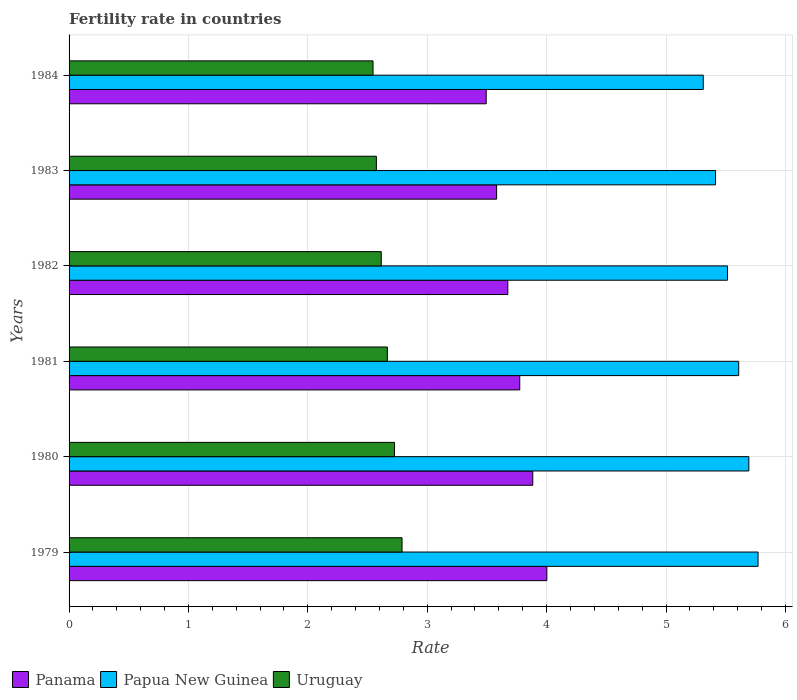Are the number of bars per tick equal to the number of legend labels?
Your response must be concise. Yes. Are the number of bars on each tick of the Y-axis equal?
Your answer should be very brief. Yes. How many bars are there on the 2nd tick from the bottom?
Provide a short and direct response. 3. In how many cases, is the number of bars for a given year not equal to the number of legend labels?
Your answer should be compact. 0. What is the fertility rate in Panama in 1980?
Your answer should be very brief. 3.88. Across all years, what is the maximum fertility rate in Papua New Guinea?
Give a very brief answer. 5.77. Across all years, what is the minimum fertility rate in Papua New Guinea?
Make the answer very short. 5.31. In which year was the fertility rate in Papua New Guinea maximum?
Provide a short and direct response. 1979. What is the total fertility rate in Panama in the graph?
Keep it short and to the point. 22.41. What is the difference between the fertility rate in Papua New Guinea in 1980 and that in 1984?
Keep it short and to the point. 0.38. What is the difference between the fertility rate in Uruguay in 1979 and the fertility rate in Papua New Guinea in 1984?
Your response must be concise. -2.52. What is the average fertility rate in Papua New Guinea per year?
Provide a succinct answer. 5.55. In the year 1981, what is the difference between the fertility rate in Panama and fertility rate in Papua New Guinea?
Ensure brevity in your answer.  -1.83. What is the ratio of the fertility rate in Panama in 1980 to that in 1982?
Keep it short and to the point. 1.06. Is the difference between the fertility rate in Panama in 1980 and 1983 greater than the difference between the fertility rate in Papua New Guinea in 1980 and 1983?
Your response must be concise. Yes. What is the difference between the highest and the second highest fertility rate in Uruguay?
Your response must be concise. 0.06. What is the difference between the highest and the lowest fertility rate in Uruguay?
Ensure brevity in your answer.  0.24. In how many years, is the fertility rate in Uruguay greater than the average fertility rate in Uruguay taken over all years?
Provide a short and direct response. 3. Is the sum of the fertility rate in Panama in 1982 and 1984 greater than the maximum fertility rate in Uruguay across all years?
Your answer should be very brief. Yes. What does the 2nd bar from the top in 1979 represents?
Offer a very short reply. Papua New Guinea. What does the 2nd bar from the bottom in 1983 represents?
Your response must be concise. Papua New Guinea. Is it the case that in every year, the sum of the fertility rate in Panama and fertility rate in Uruguay is greater than the fertility rate in Papua New Guinea?
Give a very brief answer. Yes. How many years are there in the graph?
Provide a short and direct response. 6. What is the difference between two consecutive major ticks on the X-axis?
Your response must be concise. 1. Where does the legend appear in the graph?
Provide a succinct answer. Bottom left. What is the title of the graph?
Keep it short and to the point. Fertility rate in countries. Does "Guatemala" appear as one of the legend labels in the graph?
Offer a very short reply. No. What is the label or title of the X-axis?
Your response must be concise. Rate. What is the label or title of the Y-axis?
Your answer should be very brief. Years. What is the Rate in Panama in 1979?
Offer a terse response. 4. What is the Rate in Papua New Guinea in 1979?
Your answer should be very brief. 5.77. What is the Rate of Uruguay in 1979?
Give a very brief answer. 2.79. What is the Rate in Panama in 1980?
Offer a terse response. 3.88. What is the Rate in Papua New Guinea in 1980?
Your answer should be compact. 5.69. What is the Rate of Uruguay in 1980?
Provide a succinct answer. 2.73. What is the Rate of Panama in 1981?
Your response must be concise. 3.77. What is the Rate in Papua New Guinea in 1981?
Your answer should be compact. 5.61. What is the Rate in Uruguay in 1981?
Ensure brevity in your answer.  2.67. What is the Rate in Panama in 1982?
Keep it short and to the point. 3.67. What is the Rate in Papua New Guinea in 1982?
Offer a terse response. 5.51. What is the Rate in Uruguay in 1982?
Your response must be concise. 2.62. What is the Rate of Panama in 1983?
Provide a succinct answer. 3.58. What is the Rate of Papua New Guinea in 1983?
Your answer should be compact. 5.42. What is the Rate in Uruguay in 1983?
Your answer should be very brief. 2.57. What is the Rate in Panama in 1984?
Provide a short and direct response. 3.49. What is the Rate in Papua New Guinea in 1984?
Your answer should be very brief. 5.31. What is the Rate in Uruguay in 1984?
Ensure brevity in your answer.  2.55. Across all years, what is the maximum Rate of Panama?
Provide a short and direct response. 4. Across all years, what is the maximum Rate in Papua New Guinea?
Offer a terse response. 5.77. Across all years, what is the maximum Rate in Uruguay?
Your answer should be compact. 2.79. Across all years, what is the minimum Rate of Panama?
Provide a short and direct response. 3.49. Across all years, what is the minimum Rate in Papua New Guinea?
Your response must be concise. 5.31. Across all years, what is the minimum Rate of Uruguay?
Make the answer very short. 2.55. What is the total Rate of Panama in the graph?
Provide a succinct answer. 22.41. What is the total Rate in Papua New Guinea in the graph?
Ensure brevity in your answer.  33.32. What is the total Rate in Uruguay in the graph?
Your answer should be very brief. 15.92. What is the difference between the Rate in Panama in 1979 and that in 1980?
Keep it short and to the point. 0.12. What is the difference between the Rate in Papua New Guinea in 1979 and that in 1980?
Make the answer very short. 0.08. What is the difference between the Rate in Uruguay in 1979 and that in 1980?
Give a very brief answer. 0.06. What is the difference between the Rate of Panama in 1979 and that in 1981?
Provide a short and direct response. 0.23. What is the difference between the Rate of Papua New Guinea in 1979 and that in 1981?
Keep it short and to the point. 0.16. What is the difference between the Rate in Uruguay in 1979 and that in 1981?
Offer a terse response. 0.12. What is the difference between the Rate in Panama in 1979 and that in 1982?
Offer a very short reply. 0.33. What is the difference between the Rate of Papua New Guinea in 1979 and that in 1982?
Make the answer very short. 0.26. What is the difference between the Rate in Uruguay in 1979 and that in 1982?
Provide a succinct answer. 0.17. What is the difference between the Rate in Panama in 1979 and that in 1983?
Provide a short and direct response. 0.42. What is the difference between the Rate of Papua New Guinea in 1979 and that in 1983?
Offer a very short reply. 0.36. What is the difference between the Rate of Uruguay in 1979 and that in 1983?
Your answer should be compact. 0.21. What is the difference between the Rate of Panama in 1979 and that in 1984?
Ensure brevity in your answer.  0.51. What is the difference between the Rate in Papua New Guinea in 1979 and that in 1984?
Your answer should be very brief. 0.46. What is the difference between the Rate of Uruguay in 1979 and that in 1984?
Provide a short and direct response. 0.24. What is the difference between the Rate in Panama in 1980 and that in 1981?
Give a very brief answer. 0.11. What is the difference between the Rate in Papua New Guinea in 1980 and that in 1981?
Give a very brief answer. 0.09. What is the difference between the Rate of Panama in 1980 and that in 1982?
Offer a very short reply. 0.21. What is the difference between the Rate in Papua New Guinea in 1980 and that in 1982?
Provide a short and direct response. 0.18. What is the difference between the Rate of Uruguay in 1980 and that in 1982?
Your answer should be very brief. 0.11. What is the difference between the Rate in Panama in 1980 and that in 1983?
Keep it short and to the point. 0.3. What is the difference between the Rate of Papua New Guinea in 1980 and that in 1983?
Provide a succinct answer. 0.28. What is the difference between the Rate in Uruguay in 1980 and that in 1983?
Your answer should be very brief. 0.15. What is the difference between the Rate of Panama in 1980 and that in 1984?
Provide a succinct answer. 0.39. What is the difference between the Rate in Papua New Guinea in 1980 and that in 1984?
Keep it short and to the point. 0.38. What is the difference between the Rate in Uruguay in 1980 and that in 1984?
Your answer should be compact. 0.18. What is the difference between the Rate of Papua New Guinea in 1981 and that in 1982?
Offer a very short reply. 0.09. What is the difference between the Rate of Uruguay in 1981 and that in 1982?
Your response must be concise. 0.05. What is the difference between the Rate in Panama in 1981 and that in 1983?
Your answer should be very brief. 0.19. What is the difference between the Rate of Papua New Guinea in 1981 and that in 1983?
Provide a short and direct response. 0.19. What is the difference between the Rate of Uruguay in 1981 and that in 1983?
Offer a terse response. 0.09. What is the difference between the Rate in Panama in 1981 and that in 1984?
Provide a succinct answer. 0.28. What is the difference between the Rate in Papua New Guinea in 1981 and that in 1984?
Keep it short and to the point. 0.3. What is the difference between the Rate of Uruguay in 1981 and that in 1984?
Provide a succinct answer. 0.12. What is the difference between the Rate in Panama in 1982 and that in 1983?
Keep it short and to the point. 0.09. What is the difference between the Rate of Papua New Guinea in 1982 and that in 1983?
Keep it short and to the point. 0.1. What is the difference between the Rate of Uruguay in 1982 and that in 1983?
Ensure brevity in your answer.  0.04. What is the difference between the Rate of Panama in 1982 and that in 1984?
Your answer should be very brief. 0.18. What is the difference between the Rate of Papua New Guinea in 1982 and that in 1984?
Make the answer very short. 0.2. What is the difference between the Rate in Uruguay in 1982 and that in 1984?
Keep it short and to the point. 0.07. What is the difference between the Rate in Panama in 1983 and that in 1984?
Give a very brief answer. 0.09. What is the difference between the Rate in Papua New Guinea in 1983 and that in 1984?
Your answer should be very brief. 0.1. What is the difference between the Rate of Uruguay in 1983 and that in 1984?
Provide a succinct answer. 0.03. What is the difference between the Rate in Panama in 1979 and the Rate in Papua New Guinea in 1980?
Your answer should be compact. -1.69. What is the difference between the Rate of Panama in 1979 and the Rate of Uruguay in 1980?
Your answer should be very brief. 1.28. What is the difference between the Rate of Papua New Guinea in 1979 and the Rate of Uruguay in 1980?
Offer a very short reply. 3.04. What is the difference between the Rate of Panama in 1979 and the Rate of Papua New Guinea in 1981?
Ensure brevity in your answer.  -1.61. What is the difference between the Rate of Panama in 1979 and the Rate of Uruguay in 1981?
Make the answer very short. 1.34. What is the difference between the Rate in Papua New Guinea in 1979 and the Rate in Uruguay in 1981?
Offer a terse response. 3.1. What is the difference between the Rate of Panama in 1979 and the Rate of Papua New Guinea in 1982?
Make the answer very short. -1.51. What is the difference between the Rate of Panama in 1979 and the Rate of Uruguay in 1982?
Provide a succinct answer. 1.39. What is the difference between the Rate in Papua New Guinea in 1979 and the Rate in Uruguay in 1982?
Your answer should be very brief. 3.16. What is the difference between the Rate in Panama in 1979 and the Rate in Papua New Guinea in 1983?
Your response must be concise. -1.41. What is the difference between the Rate in Panama in 1979 and the Rate in Uruguay in 1983?
Offer a terse response. 1.43. What is the difference between the Rate of Papua New Guinea in 1979 and the Rate of Uruguay in 1983?
Your answer should be compact. 3.2. What is the difference between the Rate of Panama in 1979 and the Rate of Papua New Guinea in 1984?
Your response must be concise. -1.31. What is the difference between the Rate in Panama in 1979 and the Rate in Uruguay in 1984?
Your answer should be compact. 1.46. What is the difference between the Rate in Papua New Guinea in 1979 and the Rate in Uruguay in 1984?
Make the answer very short. 3.23. What is the difference between the Rate of Panama in 1980 and the Rate of Papua New Guinea in 1981?
Provide a short and direct response. -1.73. What is the difference between the Rate in Panama in 1980 and the Rate in Uruguay in 1981?
Your answer should be very brief. 1.22. What is the difference between the Rate of Papua New Guinea in 1980 and the Rate of Uruguay in 1981?
Provide a succinct answer. 3.03. What is the difference between the Rate of Panama in 1980 and the Rate of Papua New Guinea in 1982?
Your answer should be very brief. -1.63. What is the difference between the Rate in Panama in 1980 and the Rate in Uruguay in 1982?
Ensure brevity in your answer.  1.27. What is the difference between the Rate of Papua New Guinea in 1980 and the Rate of Uruguay in 1982?
Keep it short and to the point. 3.08. What is the difference between the Rate in Panama in 1980 and the Rate in Papua New Guinea in 1983?
Offer a very short reply. -1.53. What is the difference between the Rate of Panama in 1980 and the Rate of Uruguay in 1983?
Keep it short and to the point. 1.31. What is the difference between the Rate in Papua New Guinea in 1980 and the Rate in Uruguay in 1983?
Offer a very short reply. 3.12. What is the difference between the Rate of Panama in 1980 and the Rate of Papua New Guinea in 1984?
Offer a terse response. -1.43. What is the difference between the Rate in Panama in 1980 and the Rate in Uruguay in 1984?
Provide a short and direct response. 1.34. What is the difference between the Rate in Papua New Guinea in 1980 and the Rate in Uruguay in 1984?
Your answer should be very brief. 3.15. What is the difference between the Rate of Panama in 1981 and the Rate of Papua New Guinea in 1982?
Your response must be concise. -1.74. What is the difference between the Rate of Panama in 1981 and the Rate of Uruguay in 1982?
Offer a very short reply. 1.16. What is the difference between the Rate in Papua New Guinea in 1981 and the Rate in Uruguay in 1982?
Provide a short and direct response. 2.99. What is the difference between the Rate of Panama in 1981 and the Rate of Papua New Guinea in 1983?
Give a very brief answer. -1.64. What is the difference between the Rate in Panama in 1981 and the Rate in Uruguay in 1983?
Give a very brief answer. 1.2. What is the difference between the Rate in Papua New Guinea in 1981 and the Rate in Uruguay in 1983?
Your answer should be very brief. 3.04. What is the difference between the Rate of Panama in 1981 and the Rate of Papua New Guinea in 1984?
Ensure brevity in your answer.  -1.54. What is the difference between the Rate of Panama in 1981 and the Rate of Uruguay in 1984?
Your answer should be compact. 1.23. What is the difference between the Rate in Papua New Guinea in 1981 and the Rate in Uruguay in 1984?
Offer a terse response. 3.06. What is the difference between the Rate in Panama in 1982 and the Rate in Papua New Guinea in 1983?
Your answer should be compact. -1.74. What is the difference between the Rate of Panama in 1982 and the Rate of Uruguay in 1983?
Your answer should be very brief. 1.1. What is the difference between the Rate in Papua New Guinea in 1982 and the Rate in Uruguay in 1983?
Give a very brief answer. 2.94. What is the difference between the Rate of Panama in 1982 and the Rate of Papua New Guinea in 1984?
Your response must be concise. -1.64. What is the difference between the Rate of Panama in 1982 and the Rate of Uruguay in 1984?
Make the answer very short. 1.13. What is the difference between the Rate in Papua New Guinea in 1982 and the Rate in Uruguay in 1984?
Provide a short and direct response. 2.97. What is the difference between the Rate of Panama in 1983 and the Rate of Papua New Guinea in 1984?
Ensure brevity in your answer.  -1.73. What is the difference between the Rate of Panama in 1983 and the Rate of Uruguay in 1984?
Keep it short and to the point. 1.03. What is the difference between the Rate in Papua New Guinea in 1983 and the Rate in Uruguay in 1984?
Offer a very short reply. 2.87. What is the average Rate of Panama per year?
Ensure brevity in your answer.  3.74. What is the average Rate of Papua New Guinea per year?
Offer a very short reply. 5.55. What is the average Rate of Uruguay per year?
Offer a very short reply. 2.65. In the year 1979, what is the difference between the Rate in Panama and Rate in Papua New Guinea?
Provide a short and direct response. -1.77. In the year 1979, what is the difference between the Rate in Panama and Rate in Uruguay?
Keep it short and to the point. 1.21. In the year 1979, what is the difference between the Rate in Papua New Guinea and Rate in Uruguay?
Make the answer very short. 2.98. In the year 1980, what is the difference between the Rate of Panama and Rate of Papua New Guinea?
Provide a succinct answer. -1.81. In the year 1980, what is the difference between the Rate in Panama and Rate in Uruguay?
Offer a terse response. 1.16. In the year 1980, what is the difference between the Rate in Papua New Guinea and Rate in Uruguay?
Provide a succinct answer. 2.97. In the year 1981, what is the difference between the Rate in Panama and Rate in Papua New Guinea?
Make the answer very short. -1.83. In the year 1981, what is the difference between the Rate in Panama and Rate in Uruguay?
Provide a succinct answer. 1.11. In the year 1981, what is the difference between the Rate of Papua New Guinea and Rate of Uruguay?
Your answer should be very brief. 2.94. In the year 1982, what is the difference between the Rate of Panama and Rate of Papua New Guinea?
Give a very brief answer. -1.84. In the year 1982, what is the difference between the Rate of Panama and Rate of Uruguay?
Offer a very short reply. 1.06. In the year 1983, what is the difference between the Rate in Panama and Rate in Papua New Guinea?
Provide a succinct answer. -1.83. In the year 1983, what is the difference between the Rate of Panama and Rate of Uruguay?
Ensure brevity in your answer.  1.01. In the year 1983, what is the difference between the Rate in Papua New Guinea and Rate in Uruguay?
Make the answer very short. 2.84. In the year 1984, what is the difference between the Rate of Panama and Rate of Papua New Guinea?
Offer a terse response. -1.82. In the year 1984, what is the difference between the Rate of Panama and Rate of Uruguay?
Provide a short and direct response. 0.95. In the year 1984, what is the difference between the Rate in Papua New Guinea and Rate in Uruguay?
Offer a terse response. 2.77. What is the ratio of the Rate of Panama in 1979 to that in 1980?
Provide a succinct answer. 1.03. What is the ratio of the Rate in Papua New Guinea in 1979 to that in 1980?
Provide a succinct answer. 1.01. What is the ratio of the Rate of Uruguay in 1979 to that in 1980?
Provide a succinct answer. 1.02. What is the ratio of the Rate in Panama in 1979 to that in 1981?
Your answer should be very brief. 1.06. What is the ratio of the Rate of Papua New Guinea in 1979 to that in 1981?
Provide a succinct answer. 1.03. What is the ratio of the Rate of Uruguay in 1979 to that in 1981?
Offer a terse response. 1.05. What is the ratio of the Rate of Panama in 1979 to that in 1982?
Keep it short and to the point. 1.09. What is the ratio of the Rate in Papua New Guinea in 1979 to that in 1982?
Provide a succinct answer. 1.05. What is the ratio of the Rate of Uruguay in 1979 to that in 1982?
Keep it short and to the point. 1.07. What is the ratio of the Rate in Panama in 1979 to that in 1983?
Offer a very short reply. 1.12. What is the ratio of the Rate in Papua New Guinea in 1979 to that in 1983?
Keep it short and to the point. 1.07. What is the ratio of the Rate of Uruguay in 1979 to that in 1983?
Your response must be concise. 1.08. What is the ratio of the Rate in Panama in 1979 to that in 1984?
Your answer should be very brief. 1.15. What is the ratio of the Rate of Papua New Guinea in 1979 to that in 1984?
Offer a terse response. 1.09. What is the ratio of the Rate of Uruguay in 1979 to that in 1984?
Your answer should be compact. 1.1. What is the ratio of the Rate of Panama in 1980 to that in 1981?
Ensure brevity in your answer.  1.03. What is the ratio of the Rate of Papua New Guinea in 1980 to that in 1981?
Your answer should be compact. 1.02. What is the ratio of the Rate in Uruguay in 1980 to that in 1981?
Give a very brief answer. 1.02. What is the ratio of the Rate of Panama in 1980 to that in 1982?
Offer a very short reply. 1.06. What is the ratio of the Rate in Papua New Guinea in 1980 to that in 1982?
Ensure brevity in your answer.  1.03. What is the ratio of the Rate in Uruguay in 1980 to that in 1982?
Provide a short and direct response. 1.04. What is the ratio of the Rate in Panama in 1980 to that in 1983?
Provide a succinct answer. 1.08. What is the ratio of the Rate of Papua New Guinea in 1980 to that in 1983?
Your response must be concise. 1.05. What is the ratio of the Rate of Uruguay in 1980 to that in 1983?
Your answer should be compact. 1.06. What is the ratio of the Rate in Panama in 1980 to that in 1984?
Keep it short and to the point. 1.11. What is the ratio of the Rate in Papua New Guinea in 1980 to that in 1984?
Offer a very short reply. 1.07. What is the ratio of the Rate in Uruguay in 1980 to that in 1984?
Give a very brief answer. 1.07. What is the ratio of the Rate of Panama in 1981 to that in 1982?
Offer a very short reply. 1.03. What is the ratio of the Rate of Uruguay in 1981 to that in 1982?
Make the answer very short. 1.02. What is the ratio of the Rate in Panama in 1981 to that in 1983?
Provide a short and direct response. 1.05. What is the ratio of the Rate in Papua New Guinea in 1981 to that in 1983?
Your answer should be compact. 1.04. What is the ratio of the Rate of Uruguay in 1981 to that in 1983?
Your answer should be very brief. 1.04. What is the ratio of the Rate of Panama in 1981 to that in 1984?
Offer a very short reply. 1.08. What is the ratio of the Rate in Papua New Guinea in 1981 to that in 1984?
Ensure brevity in your answer.  1.06. What is the ratio of the Rate of Uruguay in 1981 to that in 1984?
Your answer should be very brief. 1.05. What is the ratio of the Rate of Panama in 1982 to that in 1983?
Your answer should be compact. 1.03. What is the ratio of the Rate of Papua New Guinea in 1982 to that in 1983?
Ensure brevity in your answer.  1.02. What is the ratio of the Rate of Uruguay in 1982 to that in 1983?
Give a very brief answer. 1.02. What is the ratio of the Rate in Panama in 1982 to that in 1984?
Your answer should be compact. 1.05. What is the ratio of the Rate in Papua New Guinea in 1982 to that in 1984?
Your answer should be compact. 1.04. What is the ratio of the Rate in Uruguay in 1982 to that in 1984?
Give a very brief answer. 1.03. What is the ratio of the Rate of Panama in 1983 to that in 1984?
Offer a very short reply. 1.02. What is the ratio of the Rate of Papua New Guinea in 1983 to that in 1984?
Offer a terse response. 1.02. What is the ratio of the Rate in Uruguay in 1983 to that in 1984?
Make the answer very short. 1.01. What is the difference between the highest and the second highest Rate in Panama?
Your answer should be very brief. 0.12. What is the difference between the highest and the second highest Rate of Papua New Guinea?
Give a very brief answer. 0.08. What is the difference between the highest and the second highest Rate in Uruguay?
Give a very brief answer. 0.06. What is the difference between the highest and the lowest Rate of Panama?
Make the answer very short. 0.51. What is the difference between the highest and the lowest Rate in Papua New Guinea?
Provide a succinct answer. 0.46. What is the difference between the highest and the lowest Rate of Uruguay?
Your answer should be compact. 0.24. 